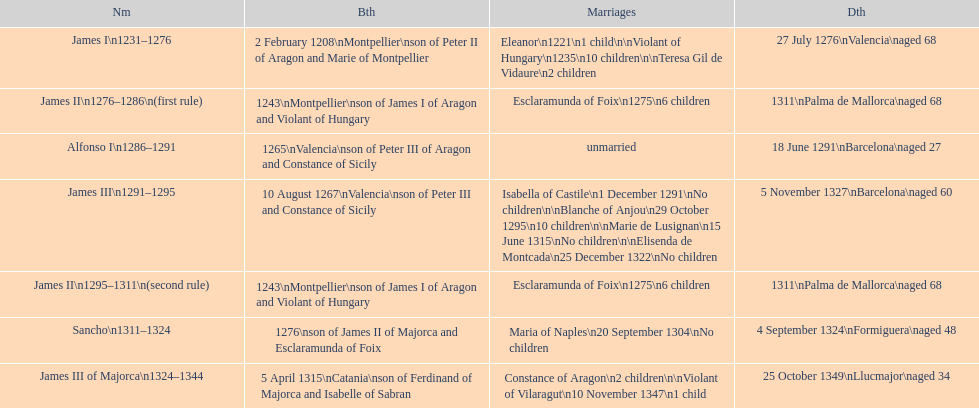Which monarch is listed first? James I 1231-1276. 